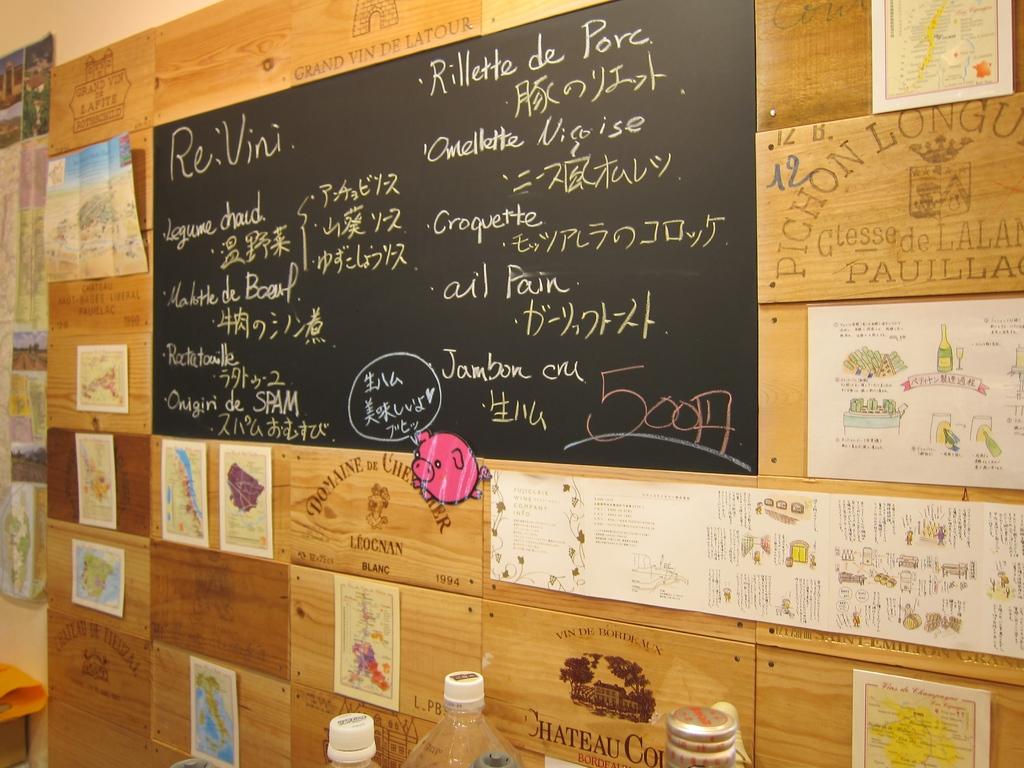What does the top of the chalkboard say?
Your answer should be very brief. Re:vini. 